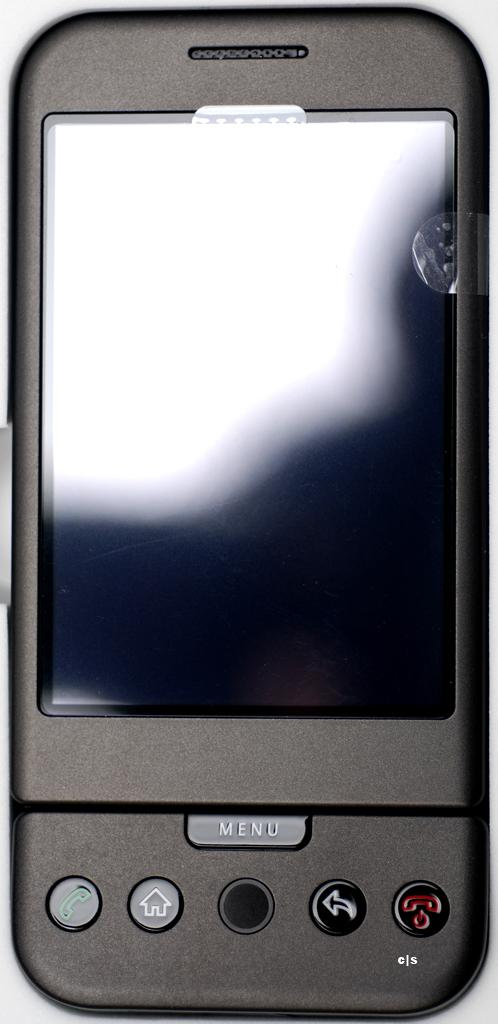<image>
Render a clear and concise summary of the photo. black cell phone that has a protector on the screen and a menu button 